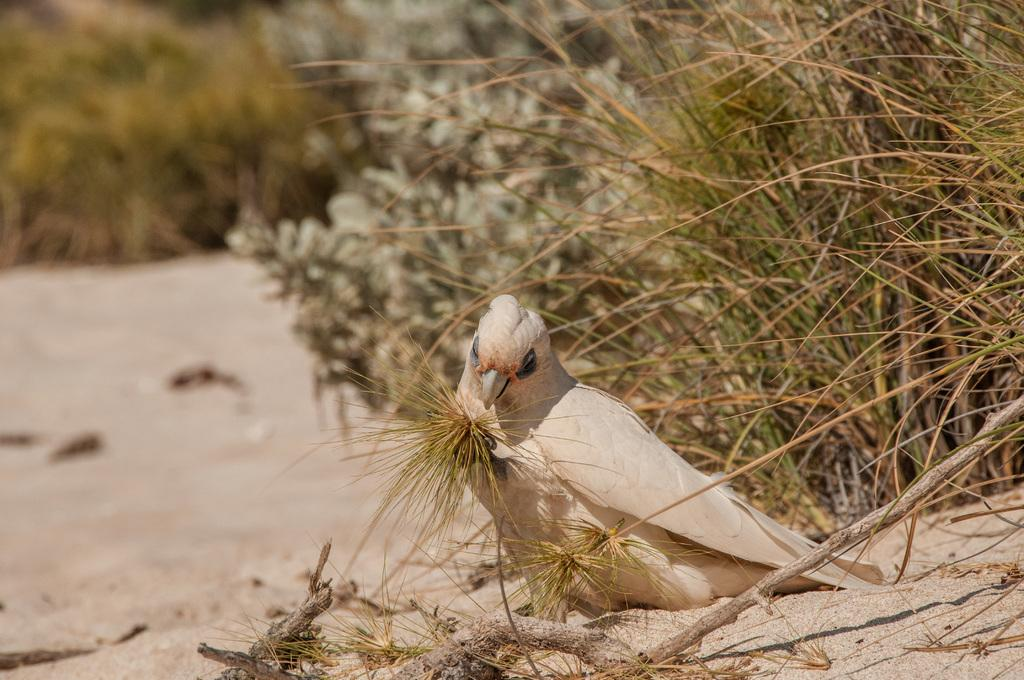What type of animal can be seen in the image? There is a bird in the image. Where is the bird located? The bird is sitting on the sand. Can you describe the bird's color? The bird has a cream and white color. What can be seen in the background of the image? There are trees visible in the background of the image, although they are blurry. What type of cord is the bird using to mark its territory in the image? There is no cord present in the image, and the bird is not marking its territory. 